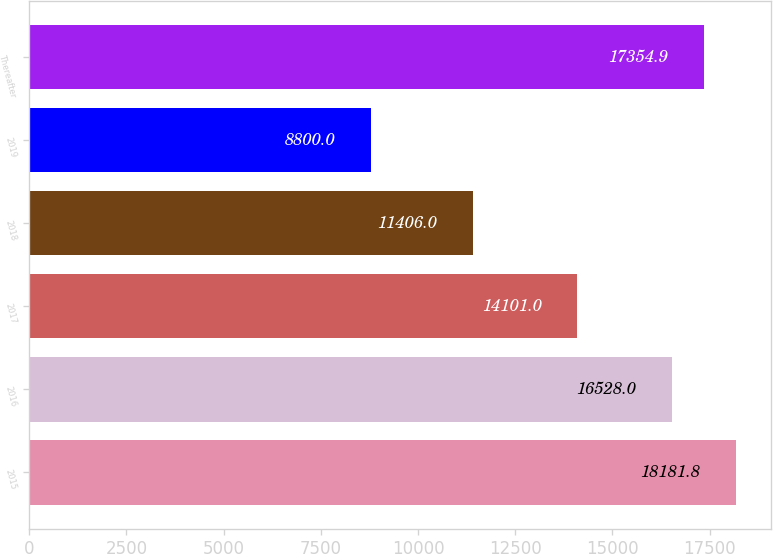Convert chart. <chart><loc_0><loc_0><loc_500><loc_500><bar_chart><fcel>2015<fcel>2016<fcel>2017<fcel>2018<fcel>2019<fcel>Thereafter<nl><fcel>18181.8<fcel>16528<fcel>14101<fcel>11406<fcel>8800<fcel>17354.9<nl></chart> 